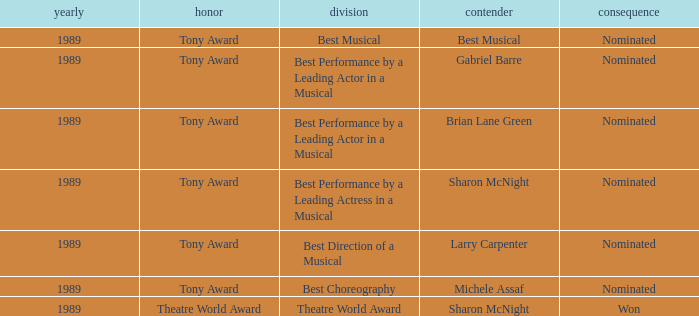What year was michele assaf nominated 1989.0. 